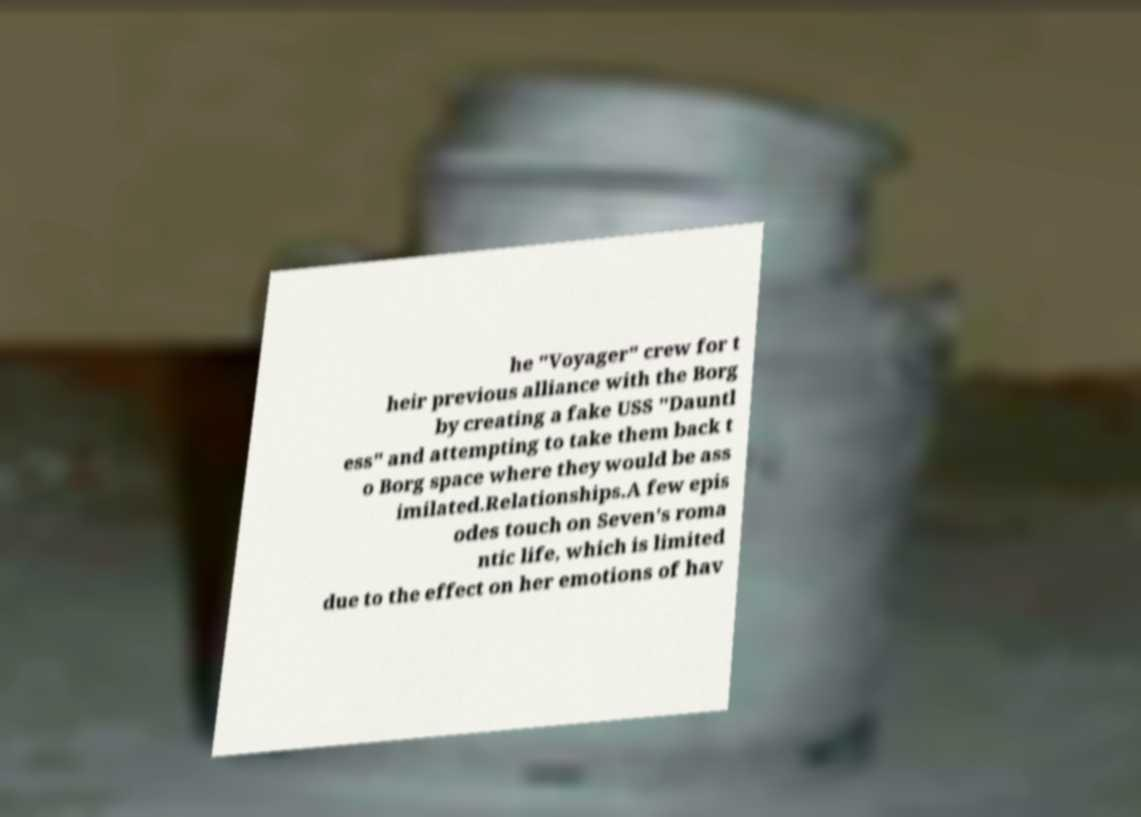Can you accurately transcribe the text from the provided image for me? he "Voyager" crew for t heir previous alliance with the Borg by creating a fake USS "Dauntl ess" and attempting to take them back t o Borg space where they would be ass imilated.Relationships.A few epis odes touch on Seven's roma ntic life, which is limited due to the effect on her emotions of hav 